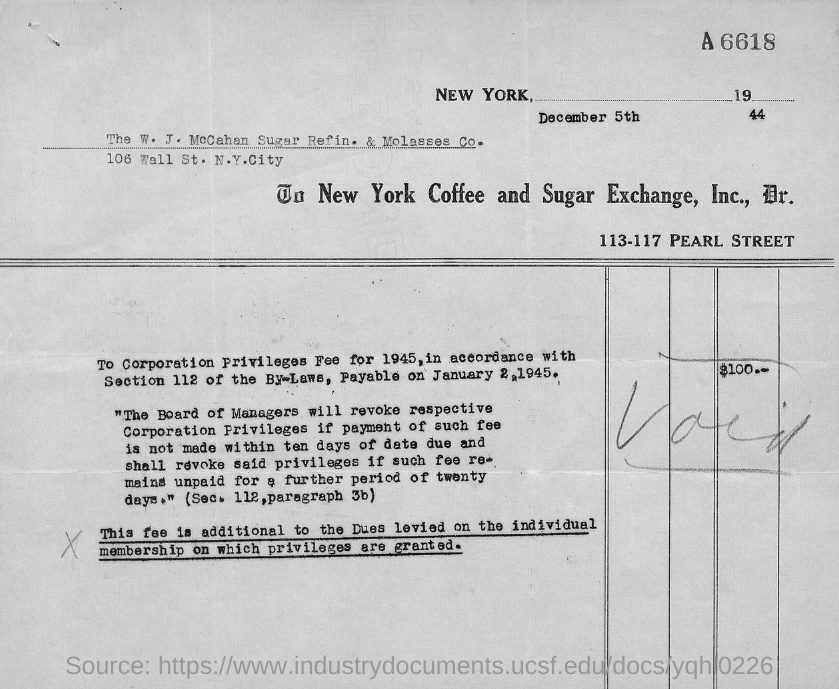Draw attention to some important aspects in this diagram. The total fee is $100. 